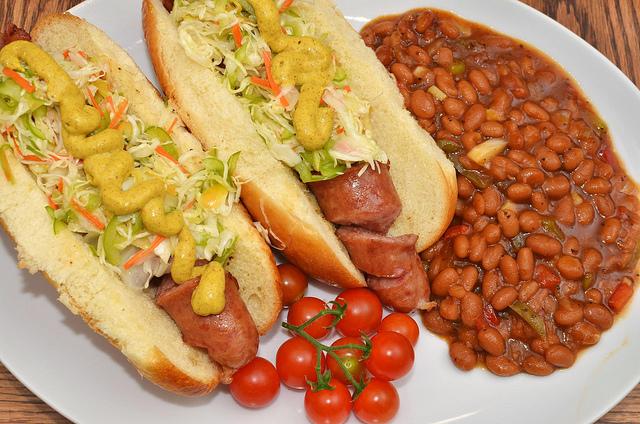Is anything made of potato?
Write a very short answer. No. What kind of food is shown?
Keep it brief. Hot dogs/beans. What condiment is on the hot dogs?
Short answer required. Mustard. What is on top of the hot dog?
Keep it brief. Mustard. What vegetables are on the plate?
Be succinct. Tomatoes. What is the greenery in between these hot dogs?
Short answer required. Lettuce. What kind of meat are these hot dogs made out of?
Write a very short answer. Pork. 